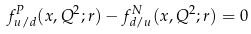Convert formula to latex. <formula><loc_0><loc_0><loc_500><loc_500>f _ { u / d } ^ { P } ( x , Q ^ { 2 } ; r ) - f _ { d / u } ^ { N } ( x , Q ^ { 2 } ; r ) = 0</formula> 